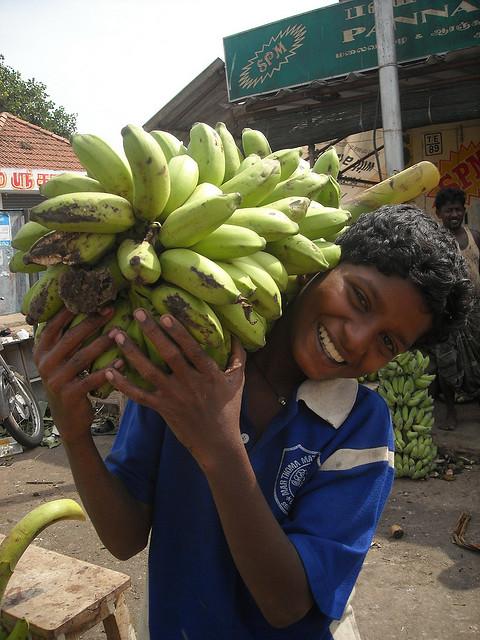Is the boy British?
Keep it brief. No. What color is the little boy's shirt?
Quick response, please. Blue. Is the boy smiling?
Be succinct. Yes. Is that enough bananas to feed Donkey Kong?
Concise answer only. Yes. 